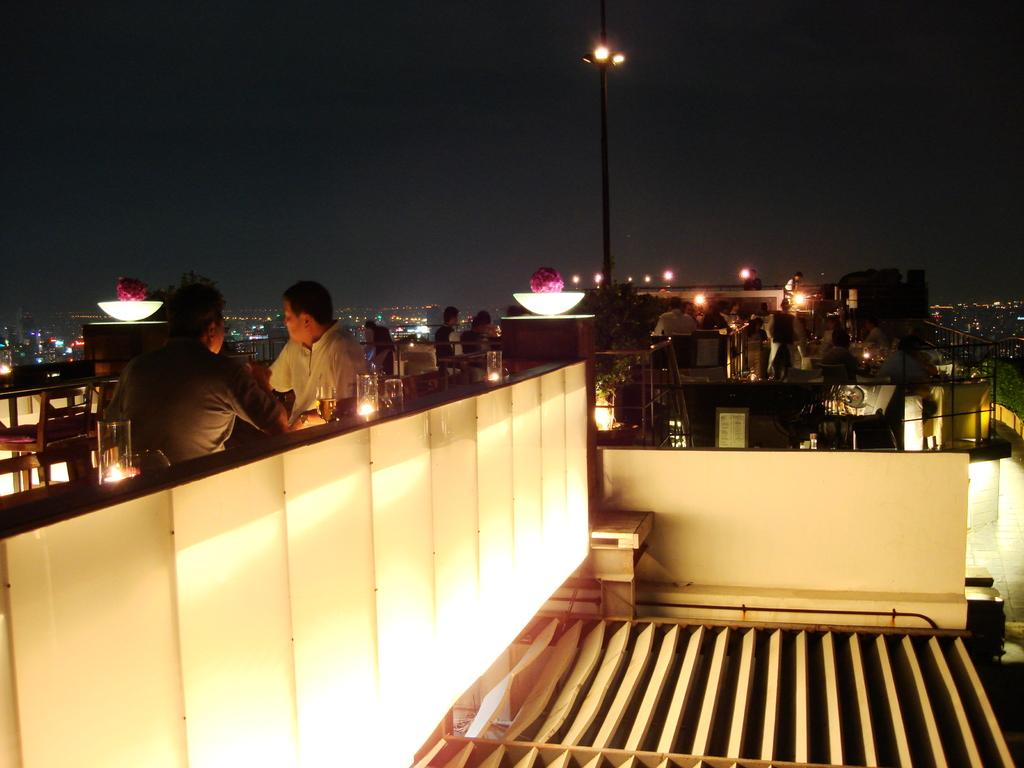What objects are in glasses in the image? There are candles in glasses in the image. What type of furniture is present in the image? There are chairs and tables in the image. What are the people in the image doing? There is a group of people sitting on the chairs in the image. What type of lighting is present in the image? There are lights in the image. What structural elements can be seen in the image? There are poles, buildings, and iron rods in the image. What part of the natural environment is visible in the image? The sky is visible in the image. How many bricks are visible in the image? There is no mention of bricks in the image, so it is not possible to determine how many are visible. What advice does the father give to the group of people in the image? There is no father or any indication of advice-giving in the image. 